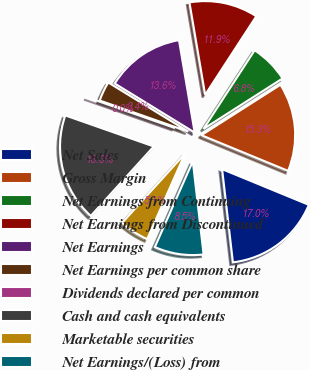Convert chart to OTSL. <chart><loc_0><loc_0><loc_500><loc_500><pie_chart><fcel>Net Sales<fcel>Gross Margin<fcel>Net Earnings from Continuing<fcel>Net Earnings from Discontinued<fcel>Net Earnings<fcel>Net Earnings per common share<fcel>Dividends declared per common<fcel>Cash and cash equivalents<fcel>Marketable securities<fcel>Net Earnings/(Loss) from<nl><fcel>16.95%<fcel>15.25%<fcel>6.78%<fcel>11.86%<fcel>13.56%<fcel>3.39%<fcel>0.0%<fcel>18.64%<fcel>5.09%<fcel>8.47%<nl></chart> 